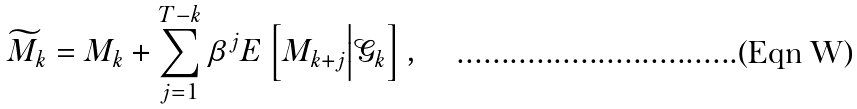<formula> <loc_0><loc_0><loc_500><loc_500>\widetilde { M } _ { k } = M _ { k } + \sum _ { j = 1 } ^ { T - k } \beta ^ { j } E \left [ M _ { k + j } \Big | \mathcal { G } _ { k } \right ] ,</formula> 